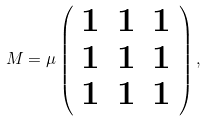Convert formula to latex. <formula><loc_0><loc_0><loc_500><loc_500>M = \mu \left ( \begin{array} { c c c } 1 & 1 & 1 \\ 1 & 1 & 1 \\ 1 & 1 & 1 \end{array} \right ) ,</formula> 